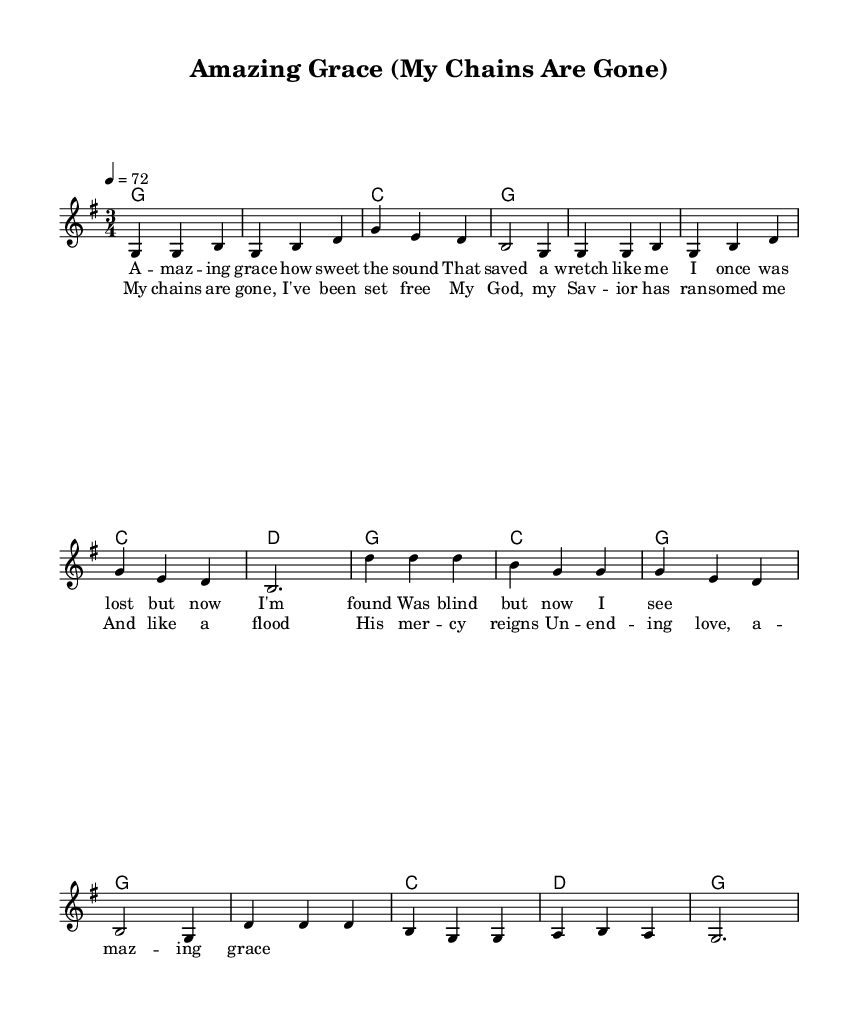what is the time signature of this music? The time signature appears at the beginning of the score and is written as 3/4, indicating that there are three beats per measure and the quarter note gets one beat.
Answer: 3/4 what key is this piece written in? The key signature can be determined from the context specified at the beginning of the score, denoted as "g major," indicating it has one sharp (F#).
Answer: G major what is the tempo marking for this piece? The tempo marking is indicated with a numerical value and a note value. It states "4 = 72," meaning that the quarter note gets 72 beats per minute, establishing the speed of the music.
Answer: 72 how many verses are included in this piece? By examining the structure outlined in the score, there is a section titled "Verse," followed by "Chorus." The word "Verse" indicates that at least one verse is present; however, only one single verse is explicitly shown before the chorus, confirming there is one verse.
Answer: One what lyrical theme does this gospel song focus on? The lyrics provided describe themes of grace, redemption, and salvation, common in traditional country gospel music. The phrases like "saved a wretch" and "My chains are gone" highlight an emphasis on personal redemption and faith.
Answer: Faith and redemption which part of the music does the chorus begin? The chorus is indicated following the verse section, and visually, it is noted clearly after the first lyrical section of the verse. The chorus starts with the musical notes, which follow the pattern of the melodies shown earlier in the score.
Answer: After the verse how does this piece reflect traditional country gospel themes? The piece reflects traditional country gospel themes through its lyrics and musical structure that focus on divine grace and personal transformation, which resonate deeply with the faith-based messages often found in the genre of country music.
Answer: Divine grace and personal transformation 